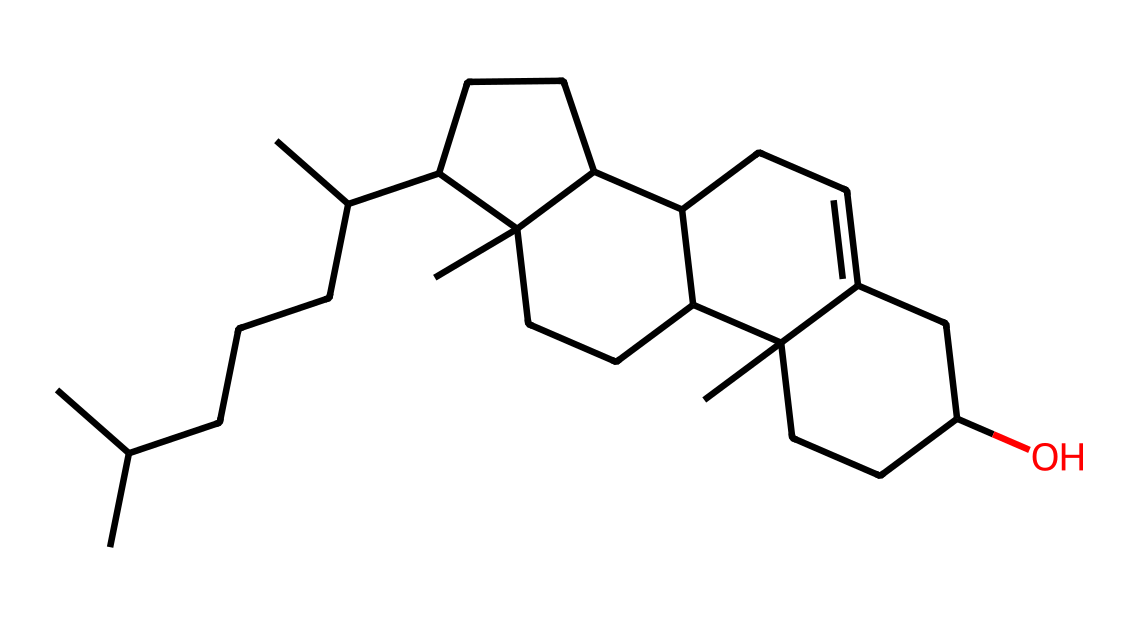What is the molecular formula of cholesterol? To determine the molecular formula, we need to count the number of carbon (C), hydrogen (H), and oxygen (O) atoms in the structure. By analyzing the SMILES representation, there are 27 carbon atoms, 46 hydrogen atoms, and 1 oxygen atom. Thus, the molecular formula is C27H46O.
Answer: C27H46O How many rings are present in cholesterol's structure? In the description of cholesterol's structure, we can identify the cyclic components. Cholesterol is classified as a steroid, which typically contains four fused rings. Upon analyzing the structure, we can fully confirm that there are four rings.
Answer: four What type of functional group is present in cholesterol? To identify the functional group, we examine the structure for notable features. Cholesterol contains a hydroxyl group (-OH) attached to one of the carbon atoms, which classifies it as an alcohol. Therefore, the functional group present in cholesterol is the hydroxyl group.
Answer: hydroxyl group Does cholesterol have any double bonds? By carefully examining the SMILES representation, we can look for double bonds between carbon atoms (C=C) or between carbon and oxygen atoms (C=O). The presence of a double bond is indicated by the "=" symbol in the SMILES, and in the case of cholesterol, there is one double bond present in the structure.
Answer: yes Is cholesterol soluble in water? Cholesterol is a non-electrolyte, and non-electrolytes typically have limited solubility in water due to their hydrophobic nature. Given the polymeric structure of cholesterol and the presence of many carbon and hydrogen atoms relative to the hydroxyl group, it can be inferred that cholesterol is not significantly soluble in water.
Answer: no How does the molecular structure of cholesterol influence its role in lipid metabolism? The structure of cholesterol includes multiple carbon rings and a hydrophobic hydrocarbon tail, which contribute to its function in membrane fluidity and as a precursor for steroid hormones. This unique physical arrangement allows cholesterol to pack within lipid membranes, thus affecting their composition and fluidity.
Answer: membrane fluidity and hormone precursor 